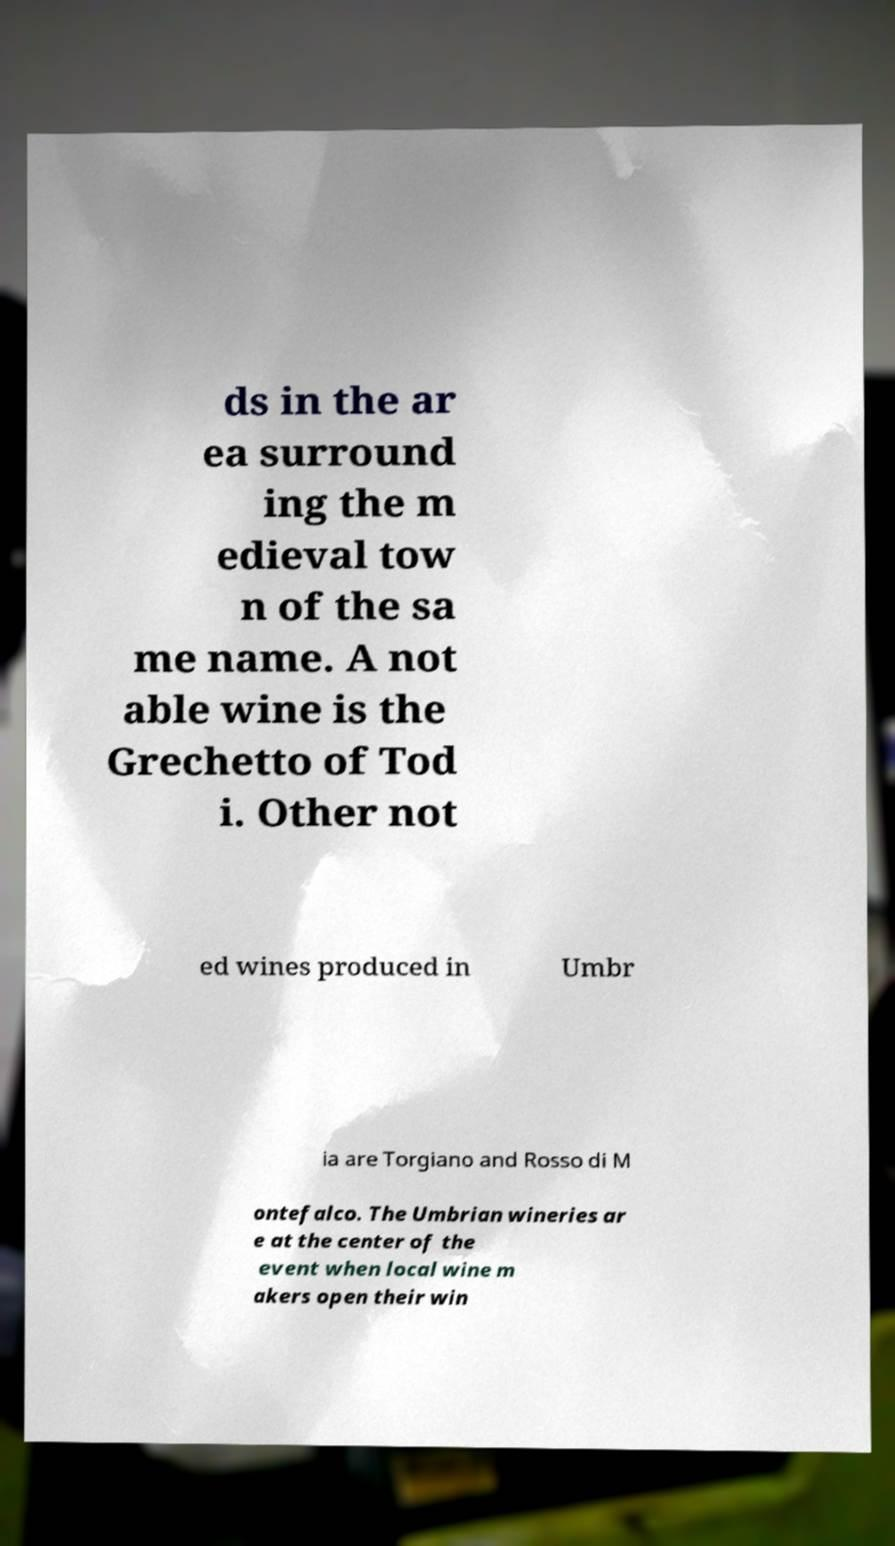Could you assist in decoding the text presented in this image and type it out clearly? ds in the ar ea surround ing the m edieval tow n of the sa me name. A not able wine is the Grechetto of Tod i. Other not ed wines produced in Umbr ia are Torgiano and Rosso di M ontefalco. The Umbrian wineries ar e at the center of the event when local wine m akers open their win 